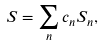<formula> <loc_0><loc_0><loc_500><loc_500>S = \sum _ { n } c _ { n } S _ { n } ,</formula> 